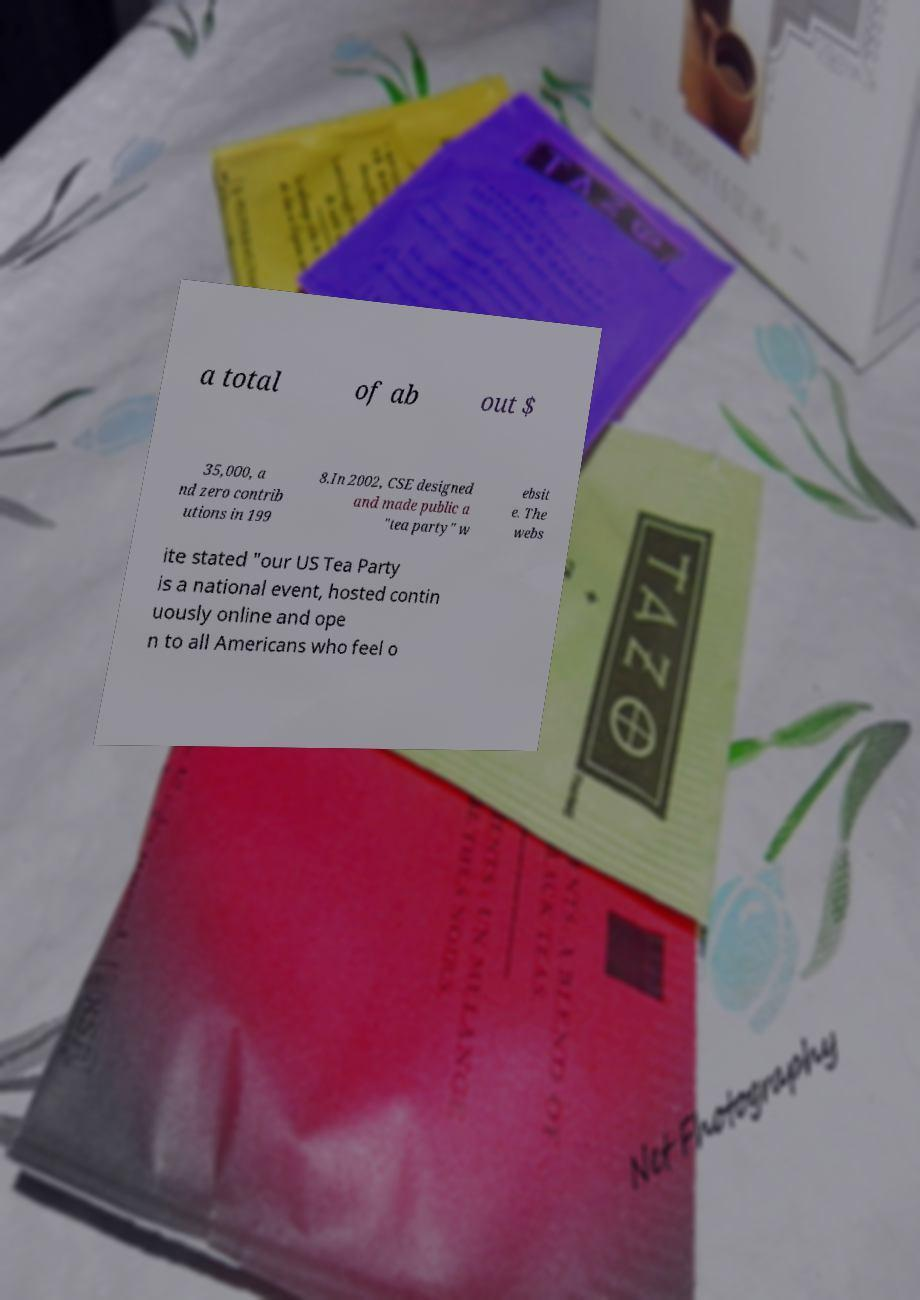I need the written content from this picture converted into text. Can you do that? a total of ab out $ 35,000, a nd zero contrib utions in 199 8.In 2002, CSE designed and made public a "tea party" w ebsit e. The webs ite stated "our US Tea Party is a national event, hosted contin uously online and ope n to all Americans who feel o 